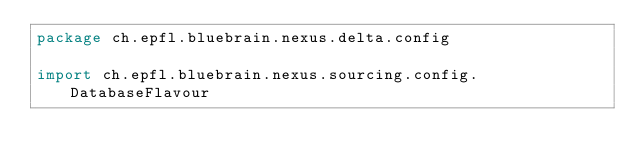<code> <loc_0><loc_0><loc_500><loc_500><_Scala_>package ch.epfl.bluebrain.nexus.delta.config

import ch.epfl.bluebrain.nexus.sourcing.config.DatabaseFlavour</code> 